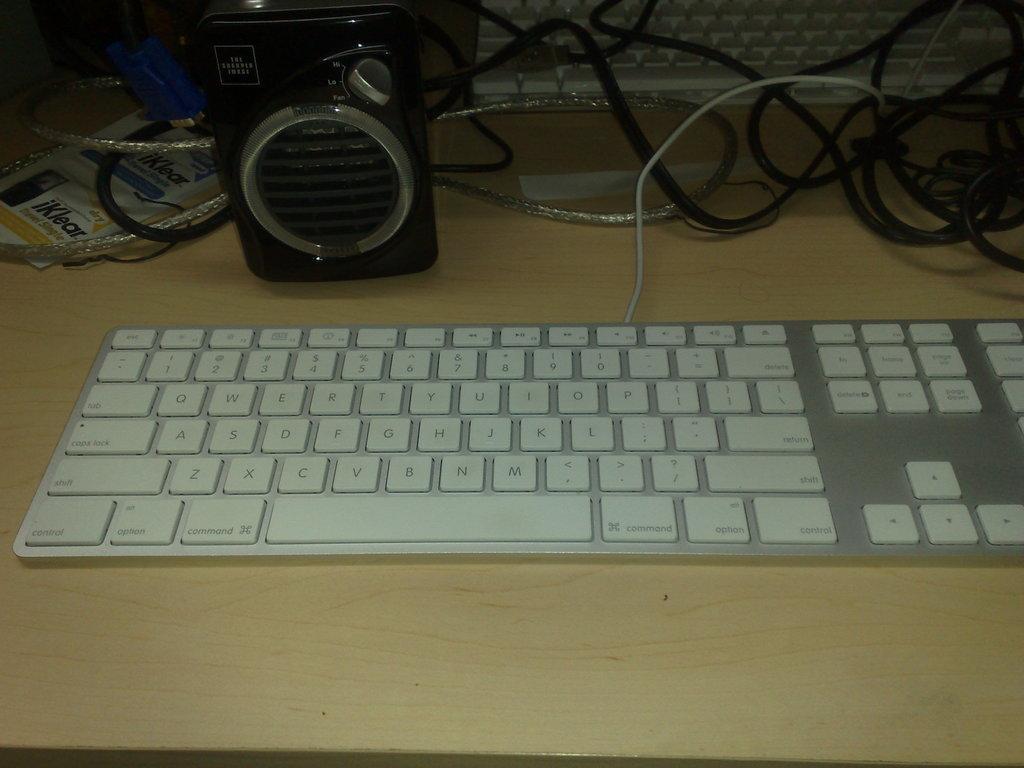In one or two sentences, can you explain what this image depicts? In this image we can see the computer keyboard, speakers and cables on the wooden surface. 